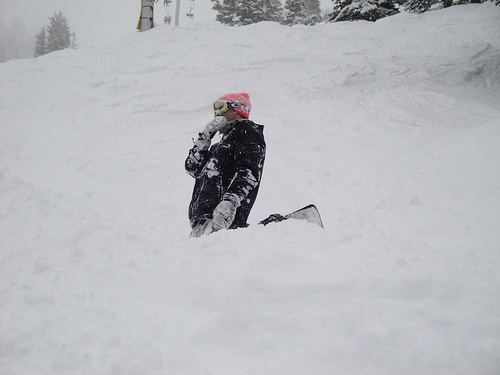Describe the objects in this image and their specific colors. I can see people in darkgray, black, gray, and lightgray tones and snowboard in darkgray, black, and gray tones in this image. 